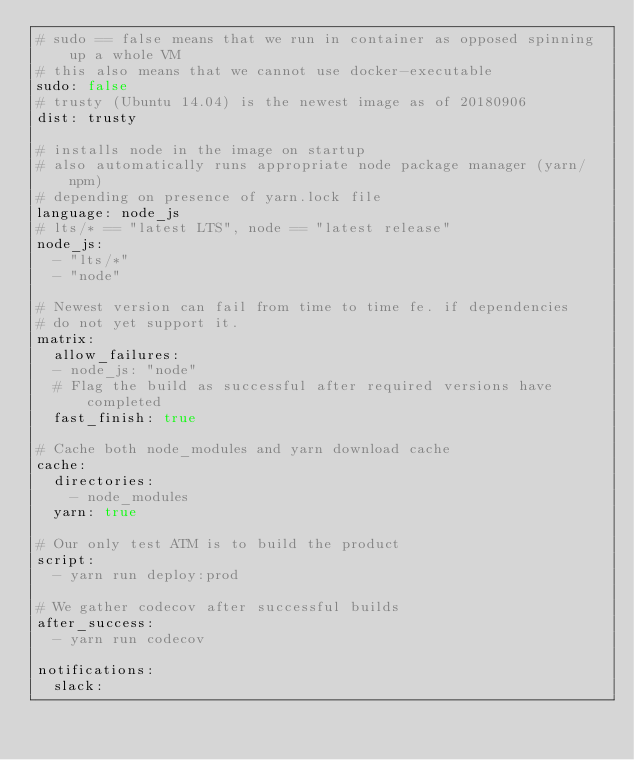Convert code to text. <code><loc_0><loc_0><loc_500><loc_500><_YAML_># sudo == false means that we run in container as opposed spinning up a whole VM
# this also means that we cannot use docker-executable
sudo: false
# trusty (Ubuntu 14.04) is the newest image as of 20180906
dist: trusty

# installs node in the image on startup
# also automatically runs appropriate node package manager (yarn/npm)
# depending on presence of yarn.lock file
language: node_js
# lts/* == "latest LTS", node == "latest release"
node_js:
  - "lts/*"
  - "node"

# Newest version can fail from time to time fe. if dependencies
# do not yet support it.
matrix:
  allow_failures:
  - node_js: "node"
  # Flag the build as successful after required versions have completed
  fast_finish: true

# Cache both node_modules and yarn download cache
cache:
  directories:
    - node_modules
  yarn: true

# Our only test ATM is to build the product
script:
  - yarn run deploy:prod

# We gather codecov after successful builds
after_success:
  - yarn run codecov

notifications:
  slack:</code> 